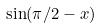<formula> <loc_0><loc_0><loc_500><loc_500>\sin ( \pi / 2 - x )</formula> 